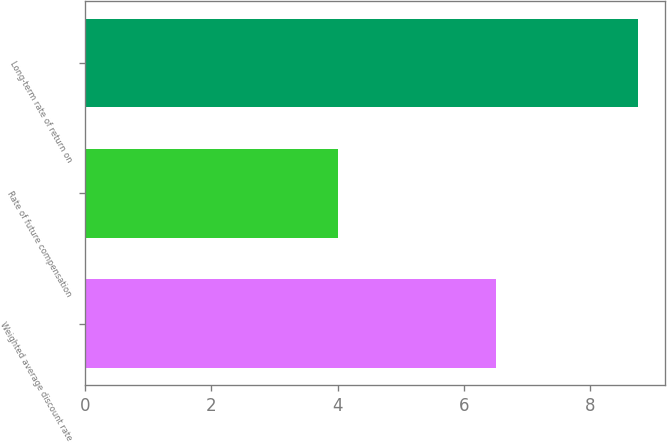Convert chart to OTSL. <chart><loc_0><loc_0><loc_500><loc_500><bar_chart><fcel>Weighted average discount rate<fcel>Rate of future compensation<fcel>Long-term rate of return on<nl><fcel>6.5<fcel>4<fcel>8.75<nl></chart> 